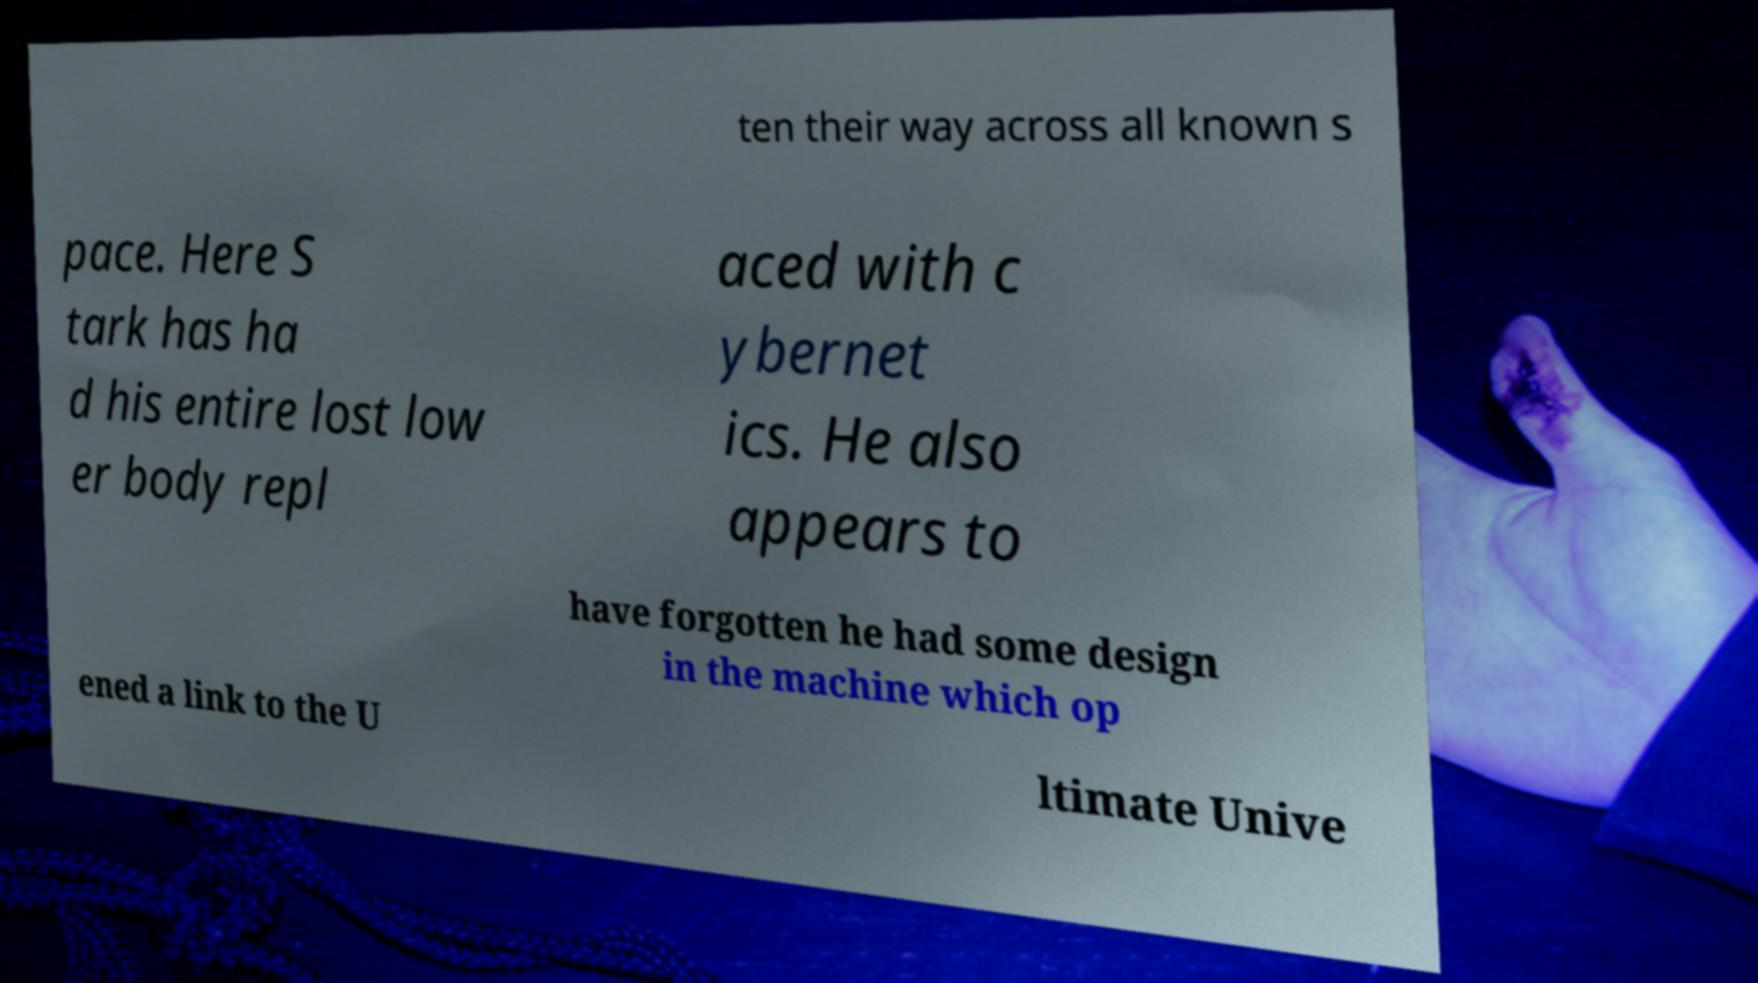I need the written content from this picture converted into text. Can you do that? ten their way across all known s pace. Here S tark has ha d his entire lost low er body repl aced with c ybernet ics. He also appears to have forgotten he had some design in the machine which op ened a link to the U ltimate Unive 